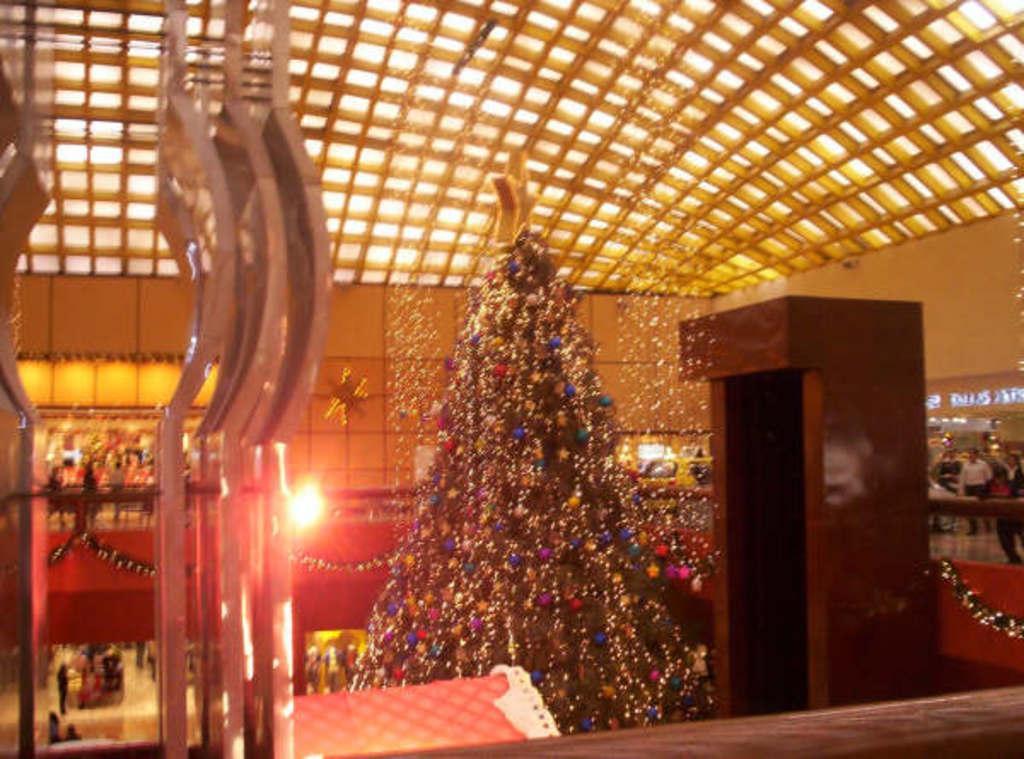Can you describe this image briefly? In the middle of the image we can see a christmas tree, in the background we can find few lights, vehicles and group of people. 